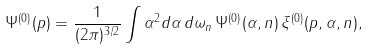<formula> <loc_0><loc_0><loc_500><loc_500>\Psi ^ { ( 0 ) } ( { p } ) = \frac { 1 } { ( 2 \pi ) ^ { 3 / 2 } } \int { \alpha } ^ { 2 } d { \alpha } \, d { \omega } _ { n } \, \Psi ^ { ( 0 ) } ( { \alpha } , { n } ) \, \xi ^ { ( 0 ) } ( { p } , { \alpha } , { n } ) ,</formula> 